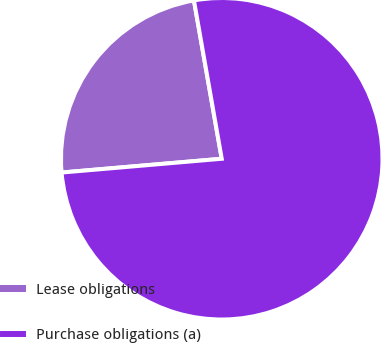Convert chart to OTSL. <chart><loc_0><loc_0><loc_500><loc_500><pie_chart><fcel>Lease obligations<fcel>Purchase obligations (a)<nl><fcel>23.6%<fcel>76.4%<nl></chart> 